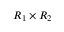<formula> <loc_0><loc_0><loc_500><loc_500>R _ { 1 } \times R _ { 2 }</formula> 